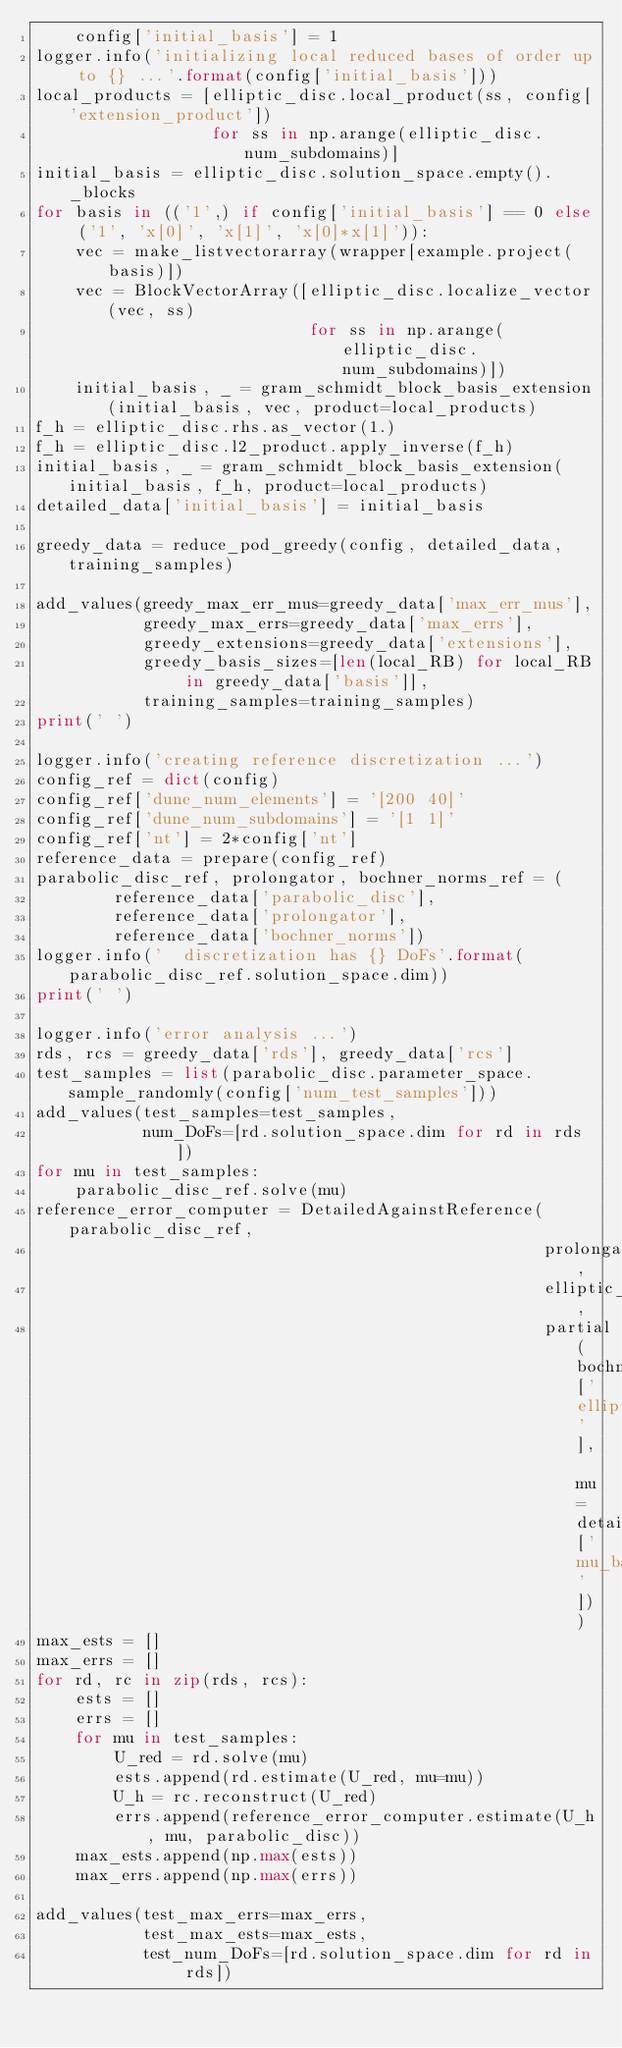Convert code to text. <code><loc_0><loc_0><loc_500><loc_500><_Python_>    config['initial_basis'] = 1
logger.info('initializing local reduced bases of order up to {} ...'.format(config['initial_basis']))
local_products = [elliptic_disc.local_product(ss, config['extension_product'])
                  for ss in np.arange(elliptic_disc.num_subdomains)]
initial_basis = elliptic_disc.solution_space.empty()._blocks
for basis in (('1',) if config['initial_basis'] == 0 else ('1', 'x[0]', 'x[1]', 'x[0]*x[1]')):
    vec = make_listvectorarray(wrapper[example.project(basis)])
    vec = BlockVectorArray([elliptic_disc.localize_vector(vec, ss)
                            for ss in np.arange(elliptic_disc.num_subdomains)])
    initial_basis, _ = gram_schmidt_block_basis_extension(initial_basis, vec, product=local_products)
f_h = elliptic_disc.rhs.as_vector(1.)
f_h = elliptic_disc.l2_product.apply_inverse(f_h)
initial_basis, _ = gram_schmidt_block_basis_extension(initial_basis, f_h, product=local_products)
detailed_data['initial_basis'] = initial_basis

greedy_data = reduce_pod_greedy(config, detailed_data, training_samples)

add_values(greedy_max_err_mus=greedy_data['max_err_mus'],
           greedy_max_errs=greedy_data['max_errs'],
           greedy_extensions=greedy_data['extensions'],
           greedy_basis_sizes=[len(local_RB) for local_RB in greedy_data['basis']],
           training_samples=training_samples)
print(' ')

logger.info('creating reference discretization ...')
config_ref = dict(config)
config_ref['dune_num_elements'] = '[200 40]'
config_ref['dune_num_subdomains'] = '[1 1]'
config_ref['nt'] = 2*config['nt']
reference_data = prepare(config_ref)
parabolic_disc_ref, prolongator, bochner_norms_ref = (
        reference_data['parabolic_disc'],
        reference_data['prolongator'],
        reference_data['bochner_norms'])
logger.info('  discretization has {} DoFs'.format(parabolic_disc_ref.solution_space.dim))
print(' ')

logger.info('error analysis ...')
rds, rcs = greedy_data['rds'], greedy_data['rcs']
test_samples = list(parabolic_disc.parameter_space.sample_randomly(config['num_test_samples']))
add_values(test_samples=test_samples,
           num_DoFs=[rd.solution_space.dim for rd in rds])
for mu in test_samples:
    parabolic_disc_ref.solve(mu)
reference_error_computer = DetailedAgainstReference(parabolic_disc_ref,
                                                    prolongator,
                                                    elliptic_disc,
                                                    partial(bochner_norms_ref['elliptic_penalty'], mu=detailed_data['mu_bar']))
max_ests = []
max_errs = []
for rd, rc in zip(rds, rcs):
    ests = []
    errs = []
    for mu in test_samples:
        U_red = rd.solve(mu)
        ests.append(rd.estimate(U_red, mu=mu))
        U_h = rc.reconstruct(U_red)
        errs.append(reference_error_computer.estimate(U_h, mu, parabolic_disc))
    max_ests.append(np.max(ests))
    max_errs.append(np.max(errs))

add_values(test_max_errs=max_errs,
           test_max_ests=max_ests,
           test_num_DoFs=[rd.solution_space.dim for rd in rds])

</code> 